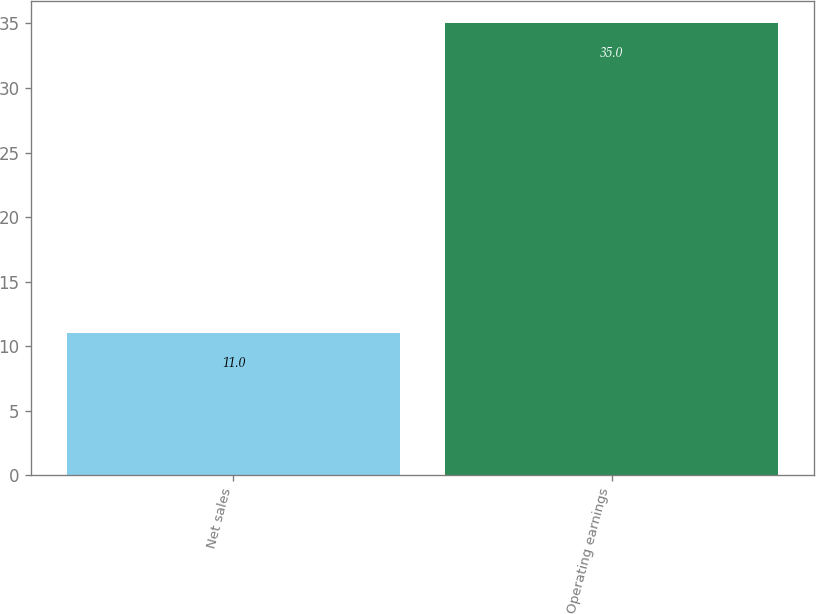Convert chart. <chart><loc_0><loc_0><loc_500><loc_500><bar_chart><fcel>Net sales<fcel>Operating earnings<nl><fcel>11<fcel>35<nl></chart> 